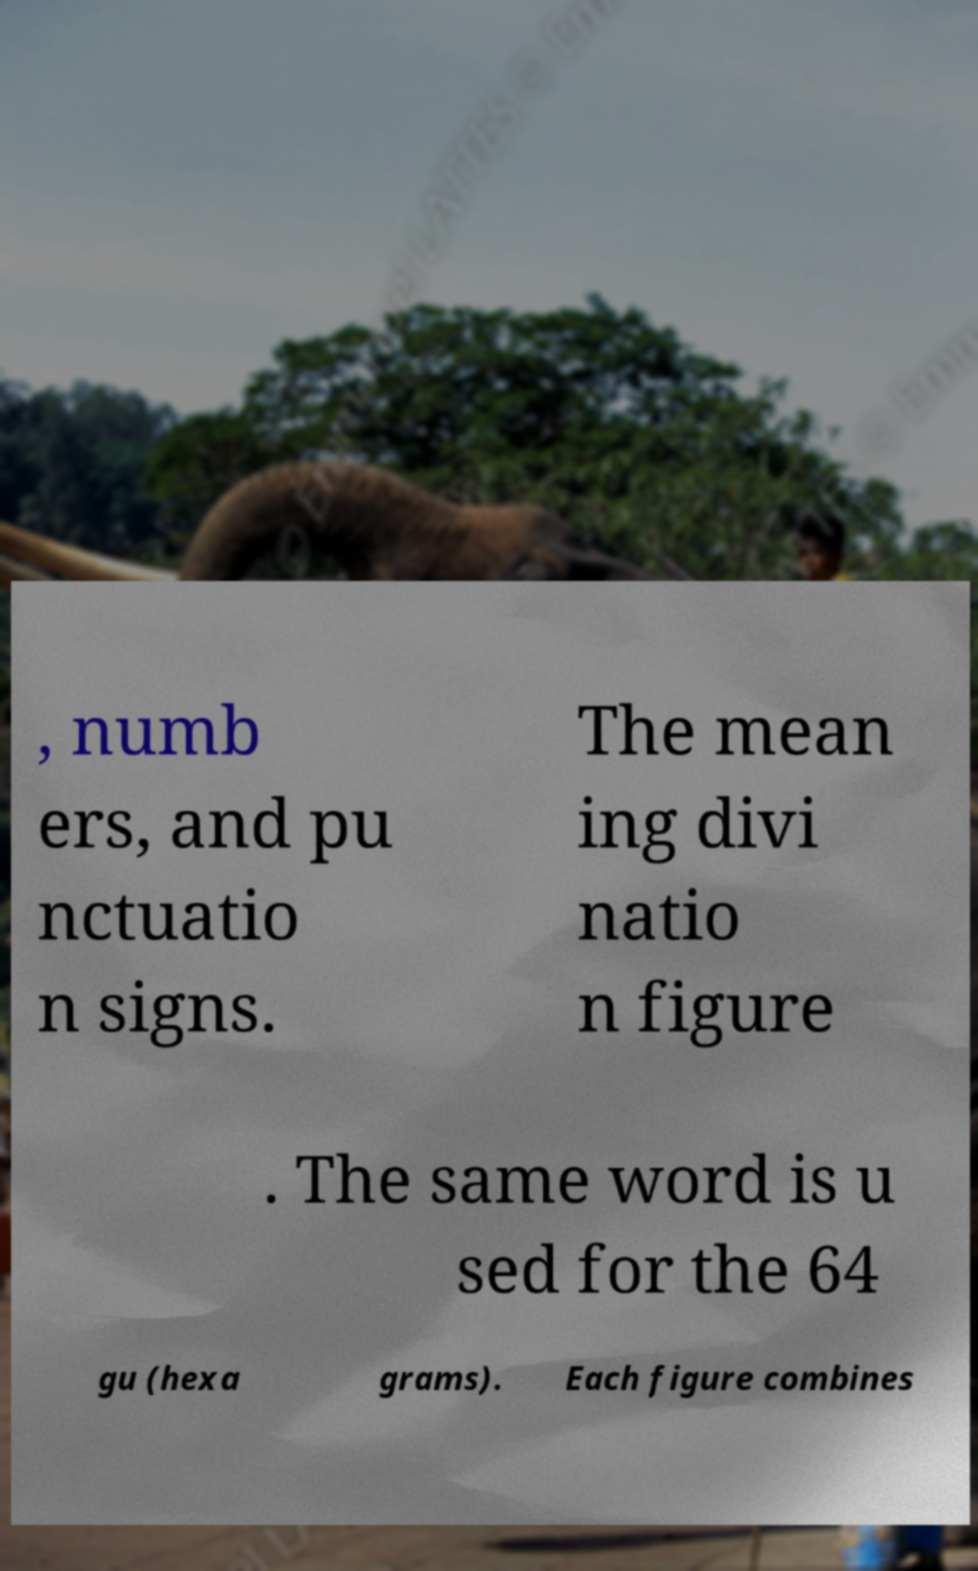I need the written content from this picture converted into text. Can you do that? , numb ers, and pu nctuatio n signs. The mean ing divi natio n figure . The same word is u sed for the 64 gu (hexa grams). Each figure combines 